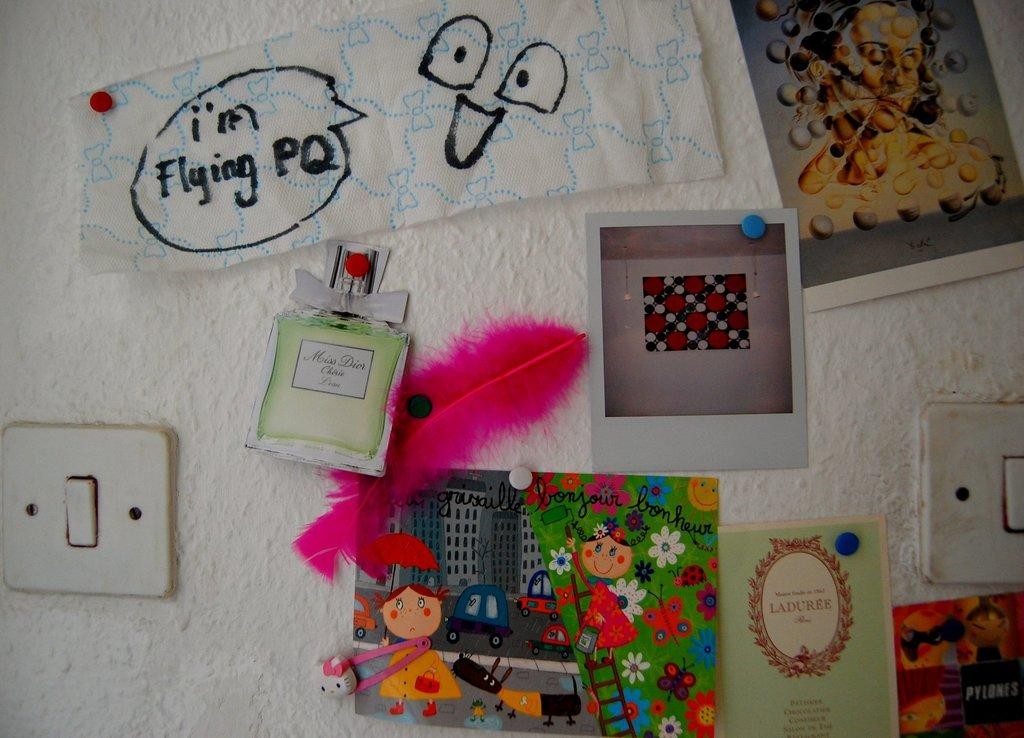<image>
Describe the image concisely. Random things on a wall including a drawing that says I'm Flying PQ. 